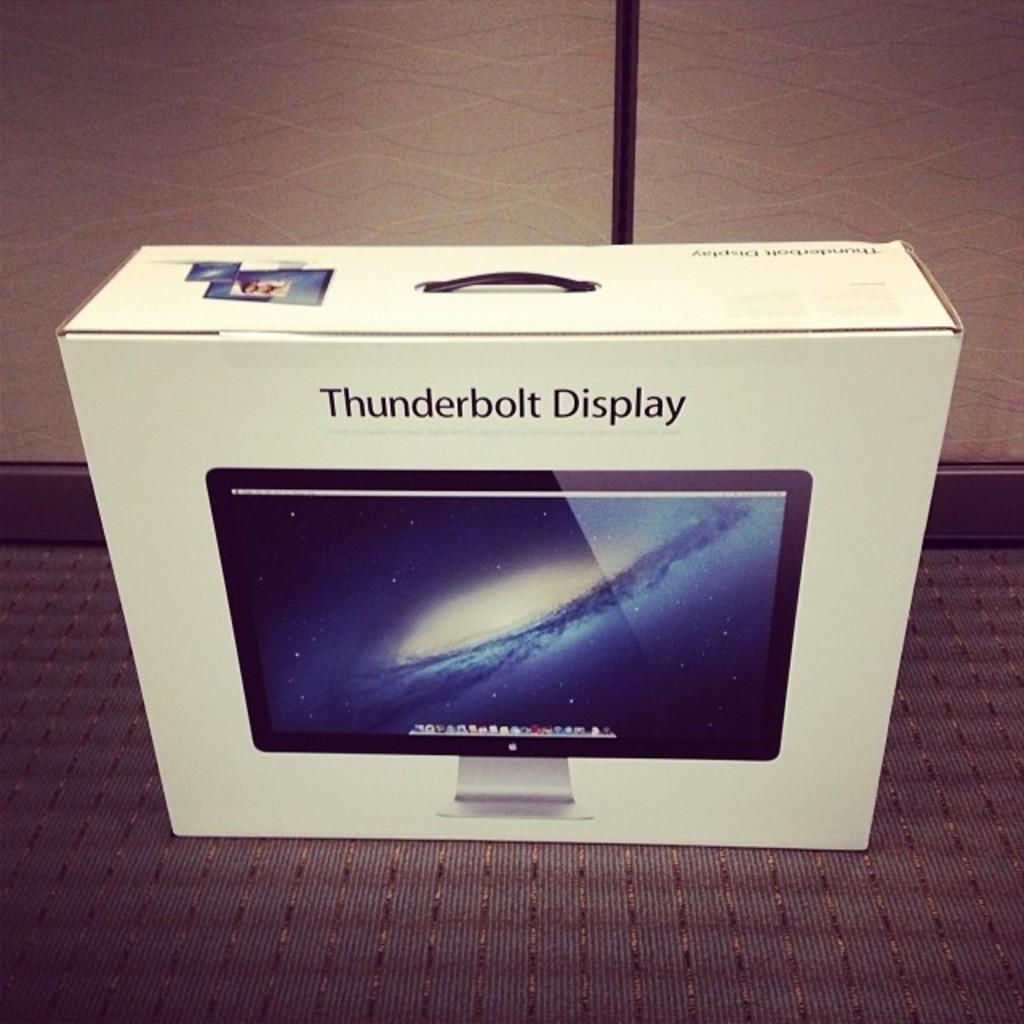Provide a one-sentence caption for the provided image. An unopened box for a Thunderbolt Display sits on a carpeted floor. 